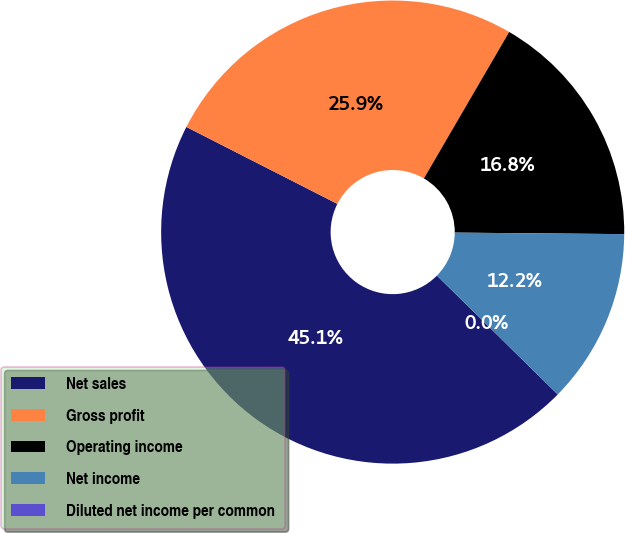<chart> <loc_0><loc_0><loc_500><loc_500><pie_chart><fcel>Net sales<fcel>Gross profit<fcel>Operating income<fcel>Net income<fcel>Diluted net income per common<nl><fcel>45.13%<fcel>25.89%<fcel>16.75%<fcel>12.23%<fcel>0.0%<nl></chart> 